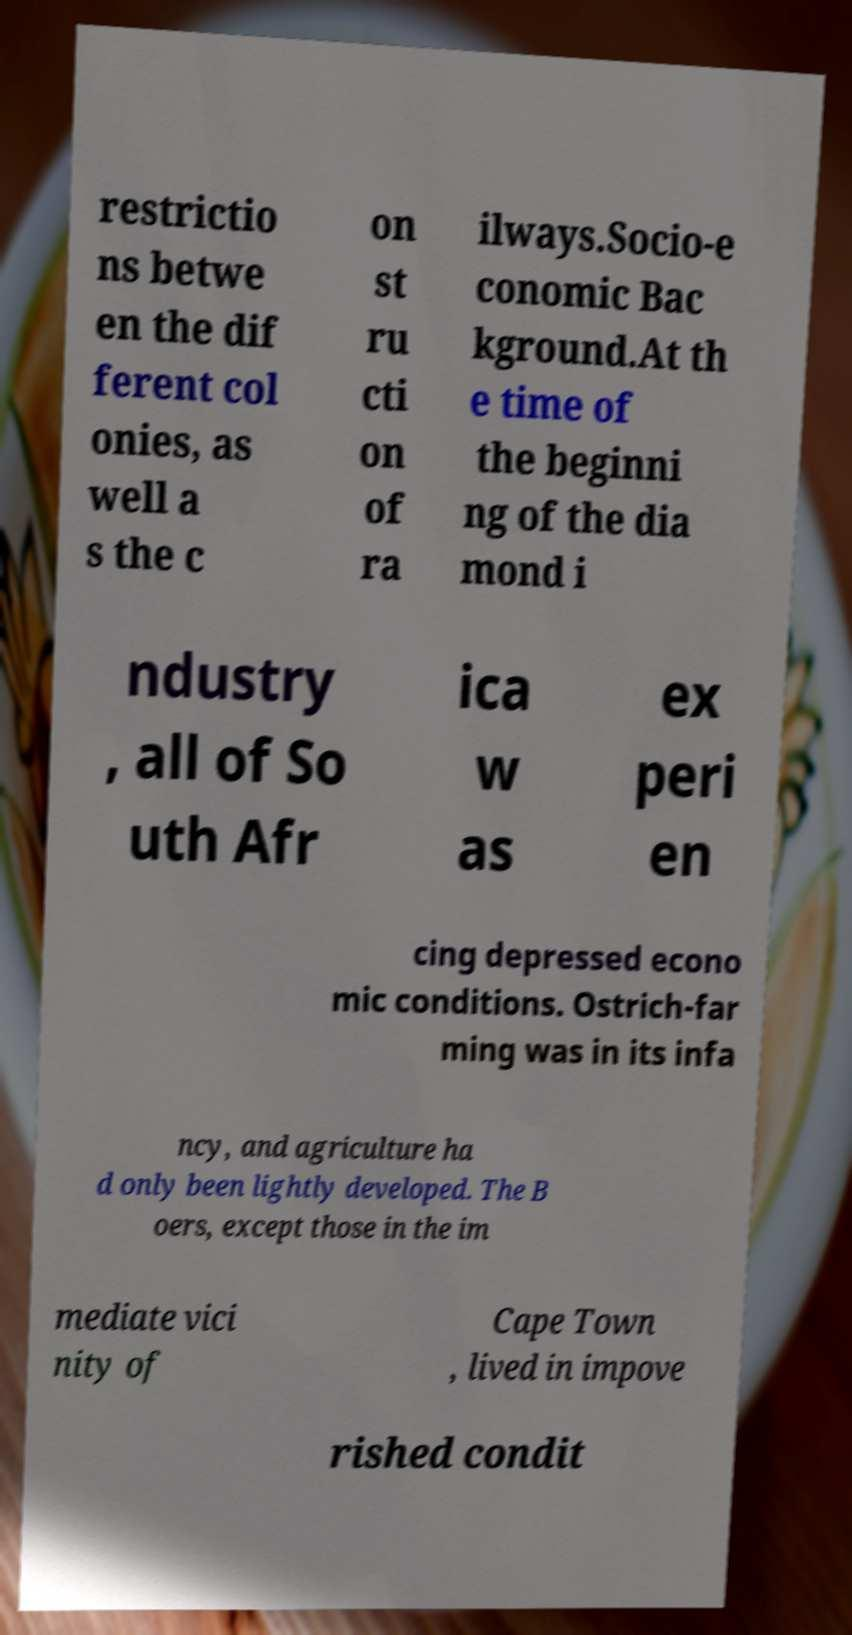Could you assist in decoding the text presented in this image and type it out clearly? restrictio ns betwe en the dif ferent col onies, as well a s the c on st ru cti on of ra ilways.Socio-e conomic Bac kground.At th e time of the beginni ng of the dia mond i ndustry , all of So uth Afr ica w as ex peri en cing depressed econo mic conditions. Ostrich-far ming was in its infa ncy, and agriculture ha d only been lightly developed. The B oers, except those in the im mediate vici nity of Cape Town , lived in impove rished condit 